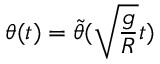Convert formula to latex. <formula><loc_0><loc_0><loc_500><loc_500>\theta ( t ) = \tilde { \theta } ( \sqrt { \frac { g } { R } } t )</formula> 